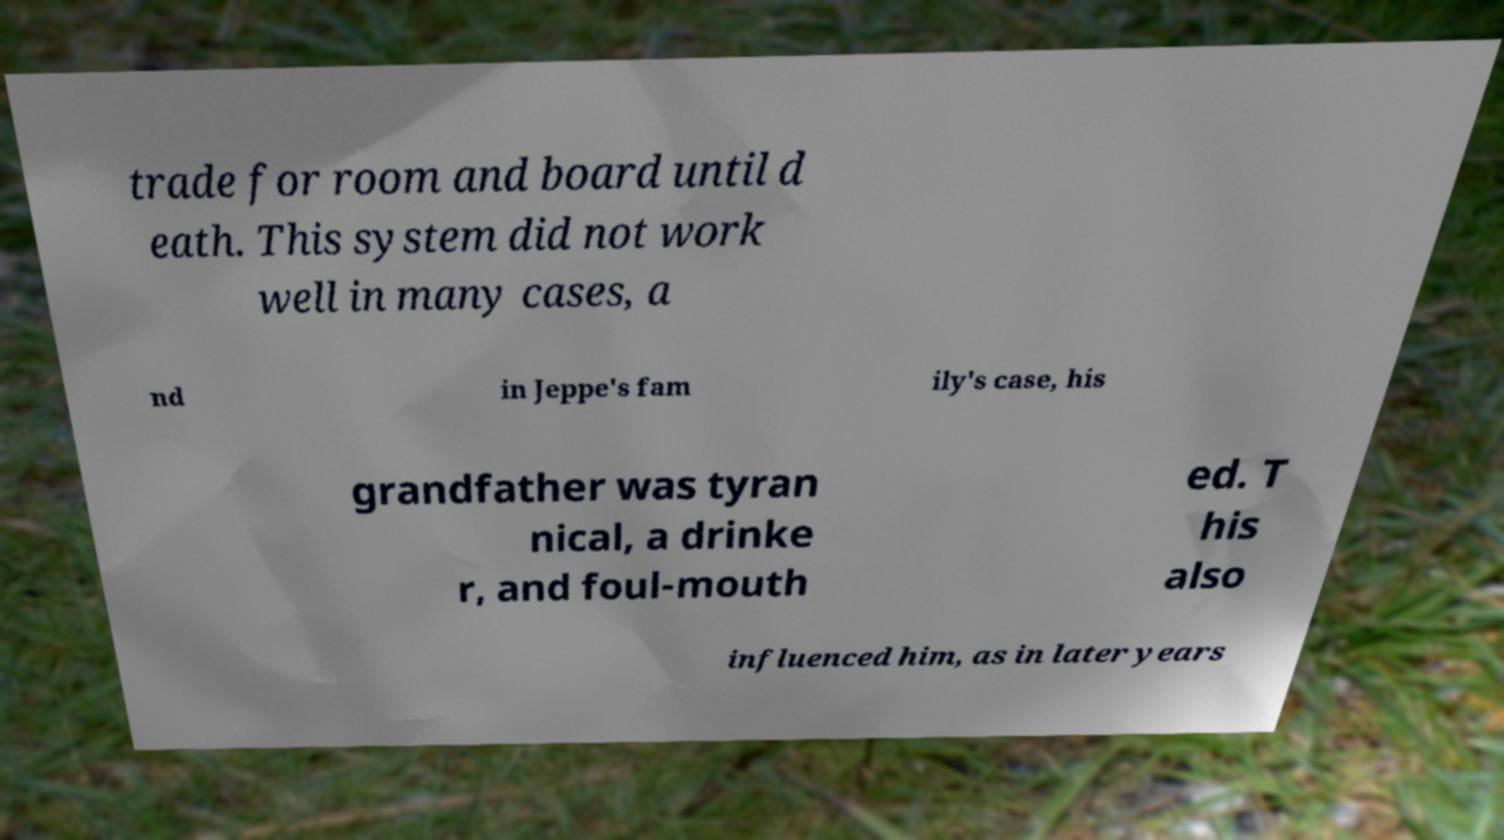Please read and relay the text visible in this image. What does it say? trade for room and board until d eath. This system did not work well in many cases, a nd in Jeppe's fam ily's case, his grandfather was tyran nical, a drinke r, and foul-mouth ed. T his also influenced him, as in later years 